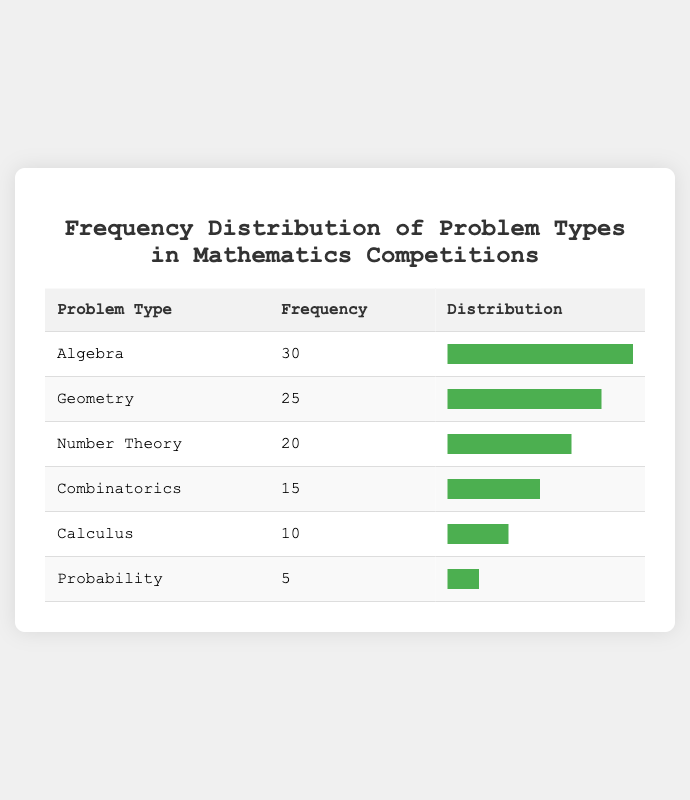What is the highest frequency of problem types in the table? The table lists the problem types along with their frequencies. We can see the highest frequency corresponds to Algebra, which has a frequency of 30.
Answer: 30 How many fewer problems are there in Probability compared to Algebra? Algebra has a frequency of 30 and Probability has a frequency of 5. To find the difference, we calculate 30 - 5 = 25.
Answer: 25 Which problem type has a frequency greater than 20? Looking through the frequencies, Algebra (30), Geometry (25), and Number Theory (20) have frequencies of 20 or more. Thus, Algebra and Geometry are the only types with a frequency greater than 20.
Answer: Algebra, Geometry What is the total frequency of Combinatorics and Calculus? Combinatorics has a frequency of 15 and Calculus has a frequency of 10. Adding these two gives us 15 + 10 = 25.
Answer: 25 Is it true that the frequency of Geometry is greater than both Combinatorics and Probability? Geometry has a frequency of 25, Combinatorics has 15, and Probability has 5. Since 25 is greater than both 15 and 5, the statement is true.
Answer: Yes What is the average frequency of all the problem types listed in the table? To calculate the average, we first need to sum all the frequencies: 30 + 25 + 20 + 15 + 10 + 5 = 105. There are 6 problem types, so we divide the total frequency by the number of types: 105 / 6 = 17.5.
Answer: 17.5 How many problem types have a frequency of 15 or less? The problem types and their frequencies are as follows: Algebra (30), Geometry (25), Number Theory (20), Combinatorics (15), Calculus (10), Probability (5). From this, Combinatorics, Calculus, and Probability have frequencies of 15 or less. Therefore, there are three types in this category.
Answer: 3 What is the frequency difference between Number Theory and Calculus? Number Theory has a frequency of 20, while Calculus has a frequency of 10. The difference is calculated as 20 - 10 = 10.
Answer: 10 Are there more problem types with a frequency less than 15 than those with a frequency of 25 or more? The types with a frequency less than 15 are only Probability (5), while those with a frequency of 25 or more are Geometry (25) and Algebra (30). Since there are 2 types with a frequency of 25 or more and 1 type with a frequency less than 15, the answer is no.
Answer: No 